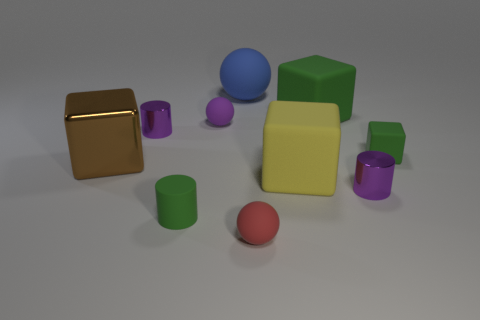There is a small object that is the same color as the small block; what material is it?
Provide a succinct answer. Rubber. What is the material of the large brown thing that is in front of the big blue rubber object behind the purple cylinder that is to the left of the large matte sphere?
Provide a short and direct response. Metal. There is a cylinder that is the same color as the tiny rubber block; what size is it?
Give a very brief answer. Small. What material is the brown block?
Your answer should be very brief. Metal. Is the big green object made of the same material as the tiny ball in front of the purple rubber ball?
Your answer should be very brief. Yes. The big block that is to the left of the matte ball that is in front of the brown block is what color?
Offer a very short reply. Brown. There is a metallic thing that is left of the big yellow matte object and on the right side of the brown object; what size is it?
Provide a succinct answer. Small. What number of other things are the same shape as the big blue object?
Provide a succinct answer. 2. There is a blue matte object; is it the same shape as the small purple metallic thing that is behind the brown object?
Provide a succinct answer. No. How many big brown metallic things are on the right side of the big blue sphere?
Your response must be concise. 0. 